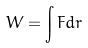<formula> <loc_0><loc_0><loc_500><loc_500>W = \int F d r</formula> 